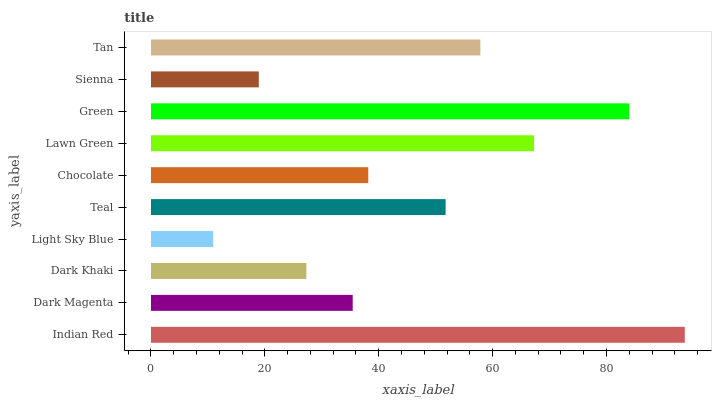Is Light Sky Blue the minimum?
Answer yes or no. Yes. Is Indian Red the maximum?
Answer yes or no. Yes. Is Dark Magenta the minimum?
Answer yes or no. No. Is Dark Magenta the maximum?
Answer yes or no. No. Is Indian Red greater than Dark Magenta?
Answer yes or no. Yes. Is Dark Magenta less than Indian Red?
Answer yes or no. Yes. Is Dark Magenta greater than Indian Red?
Answer yes or no. No. Is Indian Red less than Dark Magenta?
Answer yes or no. No. Is Teal the high median?
Answer yes or no. Yes. Is Chocolate the low median?
Answer yes or no. Yes. Is Dark Khaki the high median?
Answer yes or no. No. Is Light Sky Blue the low median?
Answer yes or no. No. 